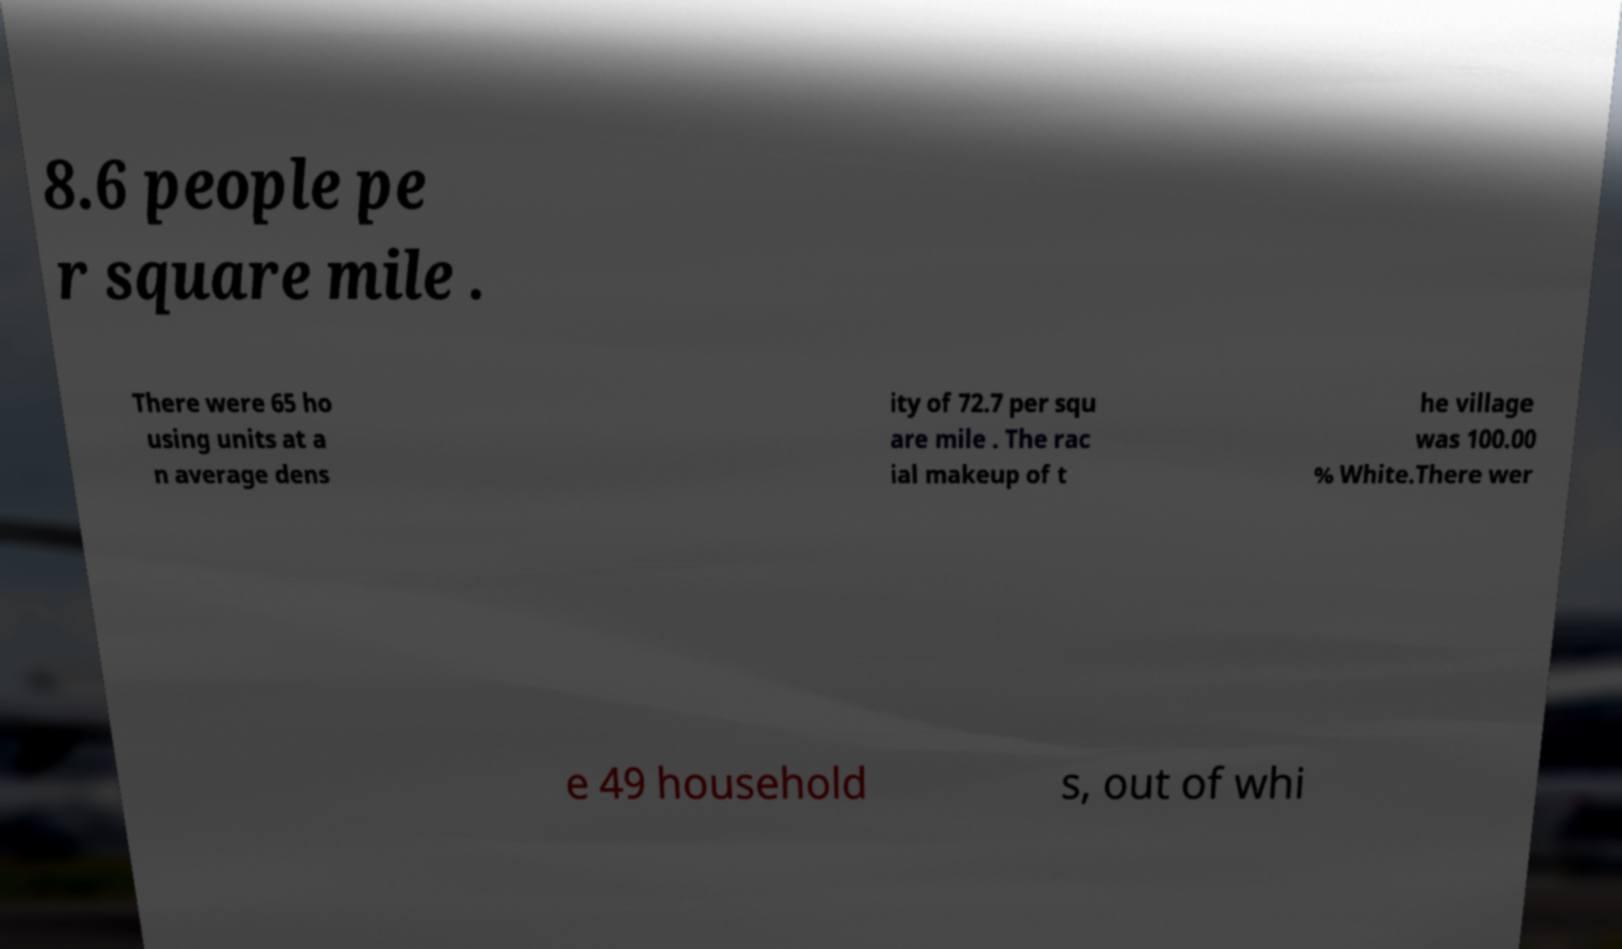For documentation purposes, I need the text within this image transcribed. Could you provide that? 8.6 people pe r square mile . There were 65 ho using units at a n average dens ity of 72.7 per squ are mile . The rac ial makeup of t he village was 100.00 % White.There wer e 49 household s, out of whi 